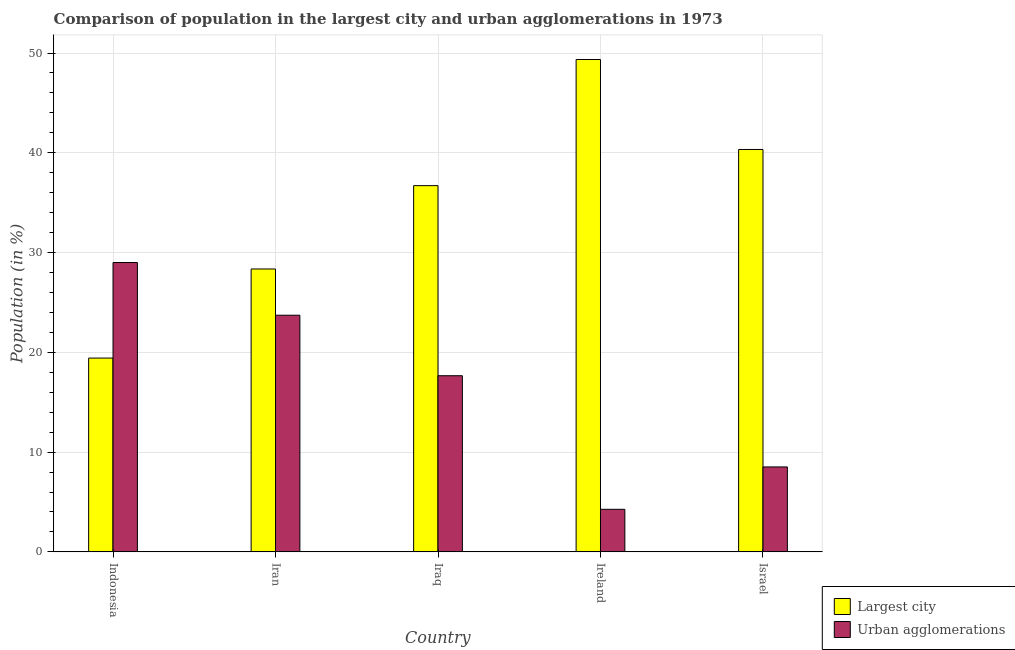How many different coloured bars are there?
Give a very brief answer. 2. How many bars are there on the 1st tick from the right?
Your answer should be compact. 2. What is the label of the 2nd group of bars from the left?
Your answer should be compact. Iran. What is the population in the largest city in Ireland?
Keep it short and to the point. 49.35. Across all countries, what is the maximum population in urban agglomerations?
Give a very brief answer. 29. Across all countries, what is the minimum population in urban agglomerations?
Make the answer very short. 4.27. In which country was the population in urban agglomerations maximum?
Offer a very short reply. Indonesia. In which country was the population in the largest city minimum?
Provide a short and direct response. Indonesia. What is the total population in the largest city in the graph?
Your answer should be very brief. 174.17. What is the difference between the population in the largest city in Iran and that in Ireland?
Your answer should be very brief. -21. What is the difference between the population in urban agglomerations in Israel and the population in the largest city in Iraq?
Your answer should be compact. -28.19. What is the average population in the largest city per country?
Your answer should be very brief. 34.83. What is the difference between the population in the largest city and population in urban agglomerations in Iraq?
Give a very brief answer. 19.05. What is the ratio of the population in urban agglomerations in Indonesia to that in Iraq?
Provide a succinct answer. 1.64. Is the population in the largest city in Indonesia less than that in Israel?
Offer a very short reply. Yes. Is the difference between the population in urban agglomerations in Indonesia and Iran greater than the difference between the population in the largest city in Indonesia and Iran?
Make the answer very short. Yes. What is the difference between the highest and the second highest population in urban agglomerations?
Keep it short and to the point. 5.28. What is the difference between the highest and the lowest population in the largest city?
Offer a very short reply. 29.93. In how many countries, is the population in urban agglomerations greater than the average population in urban agglomerations taken over all countries?
Make the answer very short. 3. What does the 2nd bar from the left in Israel represents?
Your response must be concise. Urban agglomerations. What does the 2nd bar from the right in Iran represents?
Your response must be concise. Largest city. How many bars are there?
Your response must be concise. 10. Are all the bars in the graph horizontal?
Give a very brief answer. No. Are the values on the major ticks of Y-axis written in scientific E-notation?
Offer a very short reply. No. How are the legend labels stacked?
Your answer should be compact. Vertical. What is the title of the graph?
Give a very brief answer. Comparison of population in the largest city and urban agglomerations in 1973. Does "Residents" appear as one of the legend labels in the graph?
Offer a terse response. No. What is the Population (in %) in Largest city in Indonesia?
Your answer should be compact. 19.42. What is the Population (in %) in Urban agglomerations in Indonesia?
Make the answer very short. 29. What is the Population (in %) of Largest city in Iran?
Your answer should be compact. 28.36. What is the Population (in %) in Urban agglomerations in Iran?
Provide a succinct answer. 23.72. What is the Population (in %) in Largest city in Iraq?
Offer a very short reply. 36.71. What is the Population (in %) of Urban agglomerations in Iraq?
Ensure brevity in your answer.  17.66. What is the Population (in %) in Largest city in Ireland?
Ensure brevity in your answer.  49.35. What is the Population (in %) of Urban agglomerations in Ireland?
Make the answer very short. 4.27. What is the Population (in %) in Largest city in Israel?
Your response must be concise. 40.33. What is the Population (in %) of Urban agglomerations in Israel?
Provide a short and direct response. 8.51. Across all countries, what is the maximum Population (in %) in Largest city?
Make the answer very short. 49.35. Across all countries, what is the maximum Population (in %) in Urban agglomerations?
Offer a terse response. 29. Across all countries, what is the minimum Population (in %) of Largest city?
Your answer should be very brief. 19.42. Across all countries, what is the minimum Population (in %) in Urban agglomerations?
Provide a short and direct response. 4.27. What is the total Population (in %) in Largest city in the graph?
Ensure brevity in your answer.  174.17. What is the total Population (in %) in Urban agglomerations in the graph?
Give a very brief answer. 83.16. What is the difference between the Population (in %) of Largest city in Indonesia and that in Iran?
Your answer should be very brief. -8.93. What is the difference between the Population (in %) of Urban agglomerations in Indonesia and that in Iran?
Ensure brevity in your answer.  5.28. What is the difference between the Population (in %) in Largest city in Indonesia and that in Iraq?
Provide a succinct answer. -17.28. What is the difference between the Population (in %) of Urban agglomerations in Indonesia and that in Iraq?
Offer a very short reply. 11.35. What is the difference between the Population (in %) of Largest city in Indonesia and that in Ireland?
Offer a very short reply. -29.93. What is the difference between the Population (in %) in Urban agglomerations in Indonesia and that in Ireland?
Provide a short and direct response. 24.74. What is the difference between the Population (in %) in Largest city in Indonesia and that in Israel?
Give a very brief answer. -20.91. What is the difference between the Population (in %) of Urban agglomerations in Indonesia and that in Israel?
Your response must be concise. 20.49. What is the difference between the Population (in %) in Largest city in Iran and that in Iraq?
Give a very brief answer. -8.35. What is the difference between the Population (in %) of Urban agglomerations in Iran and that in Iraq?
Your response must be concise. 6.06. What is the difference between the Population (in %) of Largest city in Iran and that in Ireland?
Give a very brief answer. -21. What is the difference between the Population (in %) in Urban agglomerations in Iran and that in Ireland?
Offer a very short reply. 19.45. What is the difference between the Population (in %) of Largest city in Iran and that in Israel?
Keep it short and to the point. -11.98. What is the difference between the Population (in %) of Urban agglomerations in Iran and that in Israel?
Make the answer very short. 15.21. What is the difference between the Population (in %) in Largest city in Iraq and that in Ireland?
Offer a very short reply. -12.64. What is the difference between the Population (in %) of Urban agglomerations in Iraq and that in Ireland?
Keep it short and to the point. 13.39. What is the difference between the Population (in %) in Largest city in Iraq and that in Israel?
Ensure brevity in your answer.  -3.63. What is the difference between the Population (in %) in Urban agglomerations in Iraq and that in Israel?
Make the answer very short. 9.14. What is the difference between the Population (in %) in Largest city in Ireland and that in Israel?
Keep it short and to the point. 9.02. What is the difference between the Population (in %) of Urban agglomerations in Ireland and that in Israel?
Your answer should be very brief. -4.25. What is the difference between the Population (in %) in Largest city in Indonesia and the Population (in %) in Urban agglomerations in Iran?
Make the answer very short. -4.29. What is the difference between the Population (in %) in Largest city in Indonesia and the Population (in %) in Urban agglomerations in Iraq?
Provide a succinct answer. 1.77. What is the difference between the Population (in %) of Largest city in Indonesia and the Population (in %) of Urban agglomerations in Ireland?
Your answer should be compact. 15.16. What is the difference between the Population (in %) of Largest city in Indonesia and the Population (in %) of Urban agglomerations in Israel?
Offer a terse response. 10.91. What is the difference between the Population (in %) in Largest city in Iran and the Population (in %) in Urban agglomerations in Iraq?
Offer a terse response. 10.7. What is the difference between the Population (in %) in Largest city in Iran and the Population (in %) in Urban agglomerations in Ireland?
Provide a short and direct response. 24.09. What is the difference between the Population (in %) in Largest city in Iran and the Population (in %) in Urban agglomerations in Israel?
Keep it short and to the point. 19.84. What is the difference between the Population (in %) of Largest city in Iraq and the Population (in %) of Urban agglomerations in Ireland?
Your answer should be compact. 32.44. What is the difference between the Population (in %) in Largest city in Iraq and the Population (in %) in Urban agglomerations in Israel?
Keep it short and to the point. 28.19. What is the difference between the Population (in %) in Largest city in Ireland and the Population (in %) in Urban agglomerations in Israel?
Keep it short and to the point. 40.84. What is the average Population (in %) of Largest city per country?
Offer a very short reply. 34.83. What is the average Population (in %) in Urban agglomerations per country?
Offer a very short reply. 16.63. What is the difference between the Population (in %) in Largest city and Population (in %) in Urban agglomerations in Indonesia?
Your answer should be very brief. -9.58. What is the difference between the Population (in %) in Largest city and Population (in %) in Urban agglomerations in Iran?
Your answer should be very brief. 4.64. What is the difference between the Population (in %) of Largest city and Population (in %) of Urban agglomerations in Iraq?
Make the answer very short. 19.05. What is the difference between the Population (in %) of Largest city and Population (in %) of Urban agglomerations in Ireland?
Keep it short and to the point. 45.09. What is the difference between the Population (in %) in Largest city and Population (in %) in Urban agglomerations in Israel?
Provide a short and direct response. 31.82. What is the ratio of the Population (in %) of Largest city in Indonesia to that in Iran?
Your answer should be compact. 0.69. What is the ratio of the Population (in %) in Urban agglomerations in Indonesia to that in Iran?
Your answer should be very brief. 1.22. What is the ratio of the Population (in %) of Largest city in Indonesia to that in Iraq?
Your answer should be compact. 0.53. What is the ratio of the Population (in %) of Urban agglomerations in Indonesia to that in Iraq?
Ensure brevity in your answer.  1.64. What is the ratio of the Population (in %) in Largest city in Indonesia to that in Ireland?
Your answer should be very brief. 0.39. What is the ratio of the Population (in %) of Urban agglomerations in Indonesia to that in Ireland?
Provide a succinct answer. 6.8. What is the ratio of the Population (in %) of Largest city in Indonesia to that in Israel?
Offer a very short reply. 0.48. What is the ratio of the Population (in %) of Urban agglomerations in Indonesia to that in Israel?
Provide a short and direct response. 3.41. What is the ratio of the Population (in %) of Largest city in Iran to that in Iraq?
Give a very brief answer. 0.77. What is the ratio of the Population (in %) in Urban agglomerations in Iran to that in Iraq?
Offer a terse response. 1.34. What is the ratio of the Population (in %) in Largest city in Iran to that in Ireland?
Give a very brief answer. 0.57. What is the ratio of the Population (in %) in Urban agglomerations in Iran to that in Ireland?
Provide a short and direct response. 5.56. What is the ratio of the Population (in %) of Largest city in Iran to that in Israel?
Your response must be concise. 0.7. What is the ratio of the Population (in %) in Urban agglomerations in Iran to that in Israel?
Provide a short and direct response. 2.79. What is the ratio of the Population (in %) in Largest city in Iraq to that in Ireland?
Keep it short and to the point. 0.74. What is the ratio of the Population (in %) of Urban agglomerations in Iraq to that in Ireland?
Give a very brief answer. 4.14. What is the ratio of the Population (in %) in Largest city in Iraq to that in Israel?
Keep it short and to the point. 0.91. What is the ratio of the Population (in %) of Urban agglomerations in Iraq to that in Israel?
Provide a short and direct response. 2.07. What is the ratio of the Population (in %) in Largest city in Ireland to that in Israel?
Give a very brief answer. 1.22. What is the ratio of the Population (in %) of Urban agglomerations in Ireland to that in Israel?
Your response must be concise. 0.5. What is the difference between the highest and the second highest Population (in %) of Largest city?
Give a very brief answer. 9.02. What is the difference between the highest and the second highest Population (in %) in Urban agglomerations?
Offer a very short reply. 5.28. What is the difference between the highest and the lowest Population (in %) of Largest city?
Offer a terse response. 29.93. What is the difference between the highest and the lowest Population (in %) in Urban agglomerations?
Make the answer very short. 24.74. 